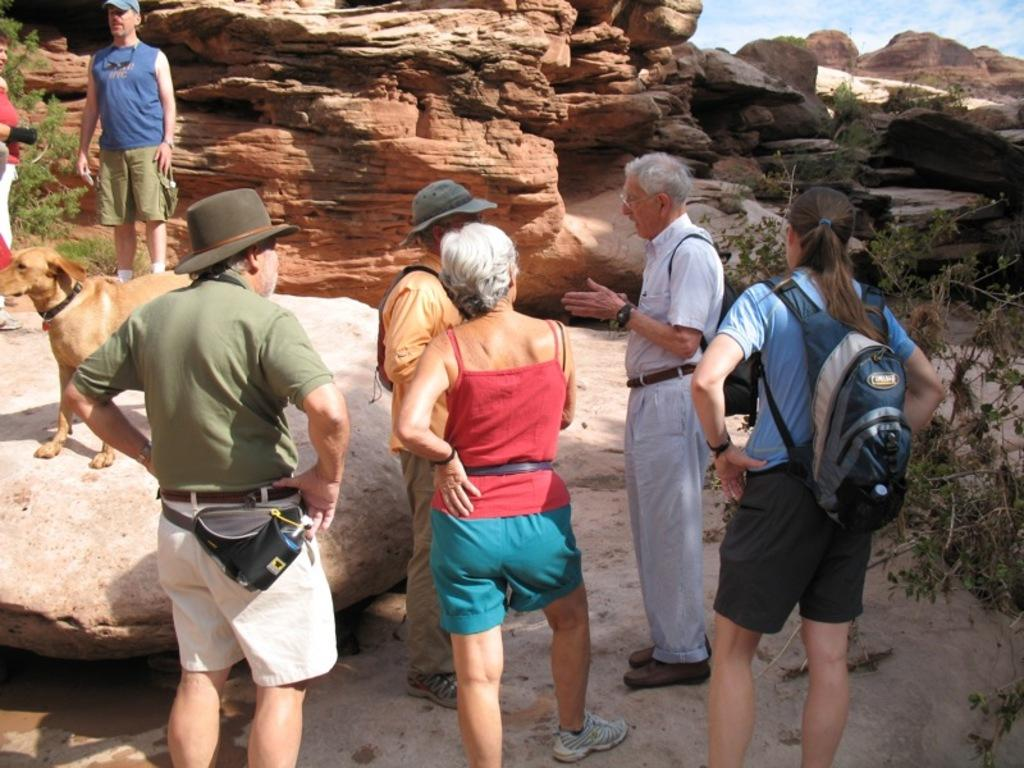What are the persons in the image standing on? The persons in the image are standing on a rock. What type of animal is present in the image? There is a dog in the image. What other object can be seen in the image? There is a plant in the image. What is the texture of the stone in the image? The stone in the image is likely rough and hard. What is visible in the background of the image? The sky is visible in the image. What type of cloth is draped over the branch in the image? There is no branch or cloth present in the image. How does the power source affect the persons standing on the rock in the image? There is no mention of a power source in the image, so its effect on the persons cannot be determined. 